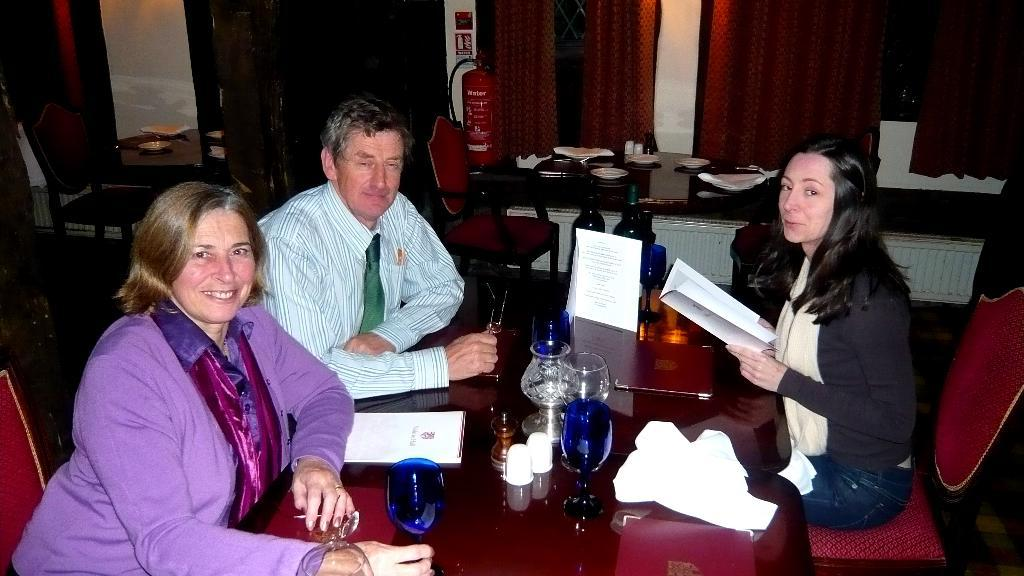How many people are in the image? There are three people in the image: two women and a man. What is the man doing in the image? The man is sitting on a chair. Where is the chair located in relation to the table? The chair is in front of the table. What can be found on the table? There are objects on the table. How many lumber pieces can be seen on the table in the image? There is no lumber present on the table in the image. Can you describe the texture of the man's legs in the image? The image does not provide enough detail to describe the texture of the man's legs. 